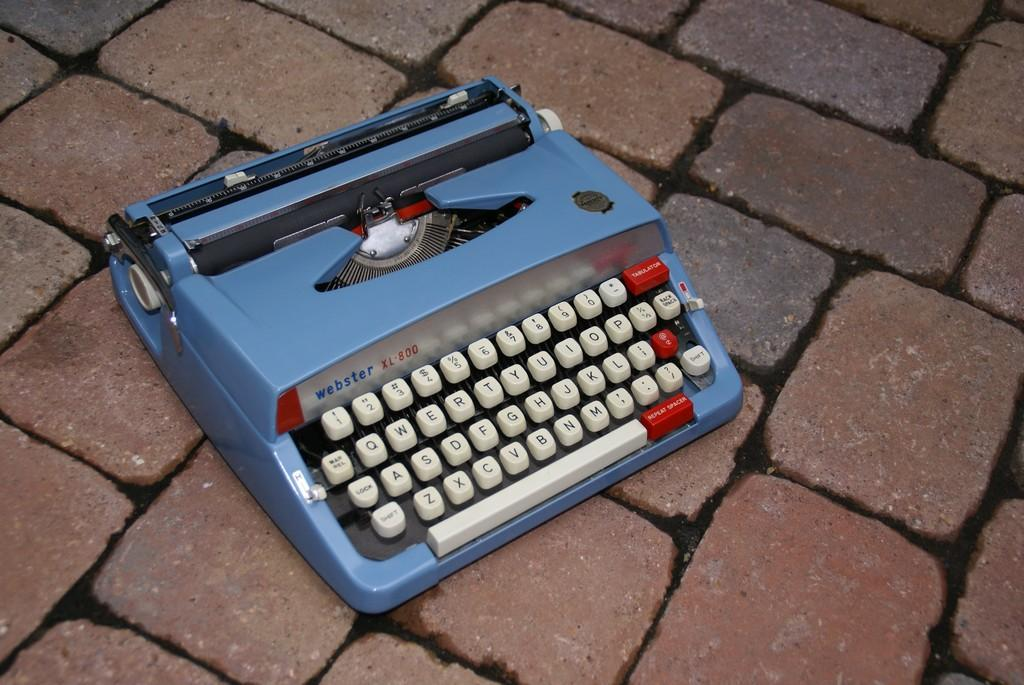<image>
Summarize the visual content of the image. A Webster XL800 vintage typewriter in powder blue. 